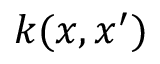Convert formula to latex. <formula><loc_0><loc_0><loc_500><loc_500>k ( x , x ^ { \prime } )</formula> 